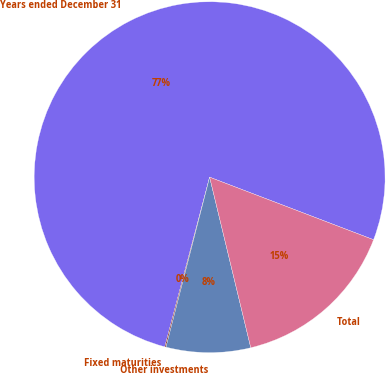Convert chart. <chart><loc_0><loc_0><loc_500><loc_500><pie_chart><fcel>Years ended December 31<fcel>Fixed maturities<fcel>Other investments<fcel>Total<nl><fcel>76.69%<fcel>0.11%<fcel>7.77%<fcel>15.43%<nl></chart> 